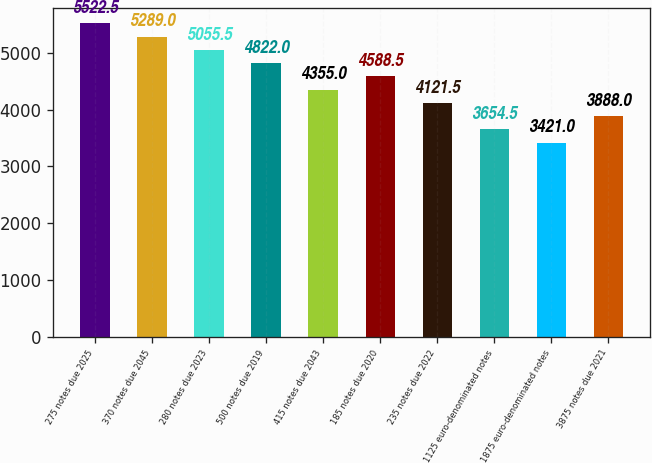<chart> <loc_0><loc_0><loc_500><loc_500><bar_chart><fcel>275 notes due 2025<fcel>370 notes due 2045<fcel>280 notes due 2023<fcel>500 notes due 2019<fcel>415 notes due 2043<fcel>185 notes due 2020<fcel>235 notes due 2022<fcel>1125 euro-denominated notes<fcel>1875 euro-denominated notes<fcel>3875 notes due 2021<nl><fcel>5522.5<fcel>5289<fcel>5055.5<fcel>4822<fcel>4355<fcel>4588.5<fcel>4121.5<fcel>3654.5<fcel>3421<fcel>3888<nl></chart> 